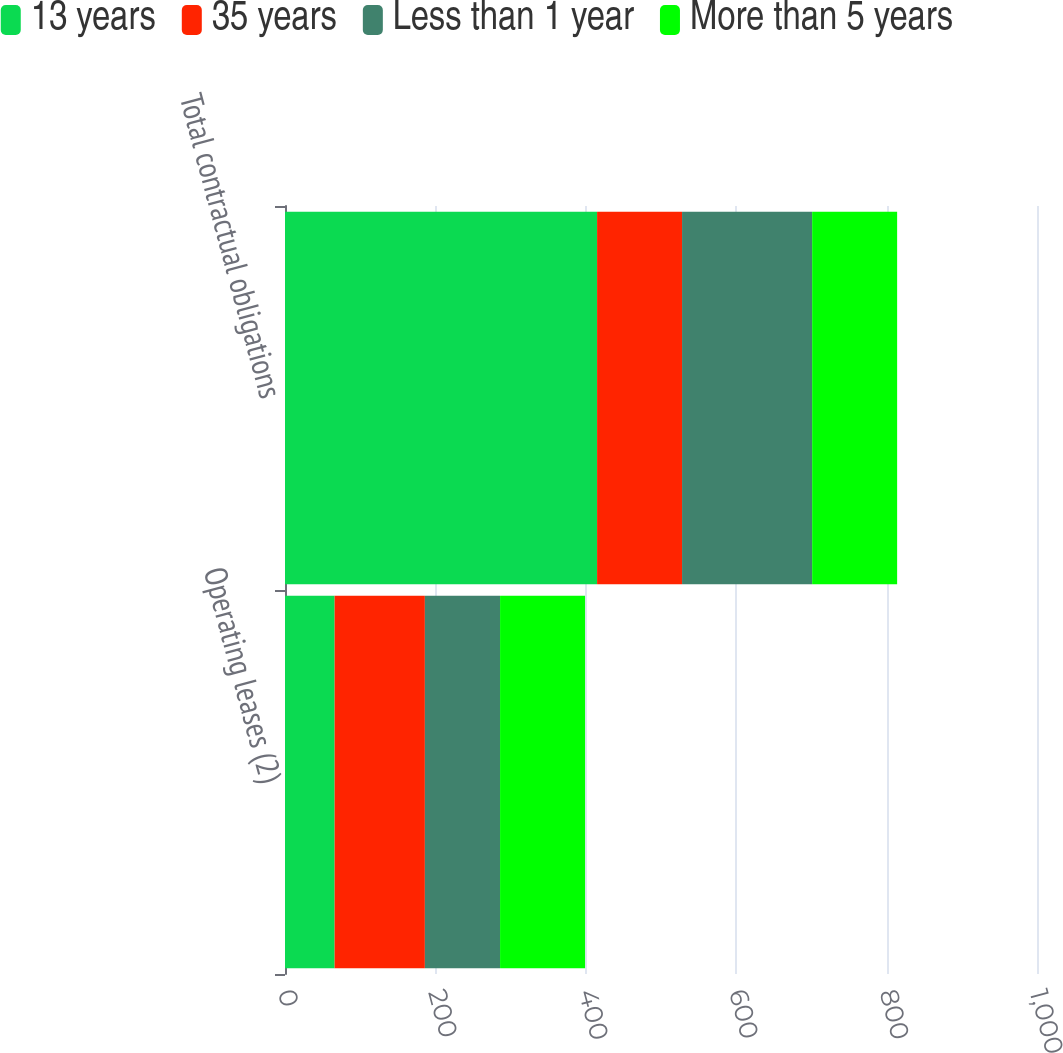<chart> <loc_0><loc_0><loc_500><loc_500><stacked_bar_chart><ecel><fcel>Operating leases (2)<fcel>Total contractual obligations<nl><fcel>13 years<fcel>66<fcel>415<nl><fcel>35 years<fcel>120<fcel>113<nl><fcel>Less than 1 year<fcel>100<fcel>173<nl><fcel>More than 5 years<fcel>113<fcel>113<nl></chart> 